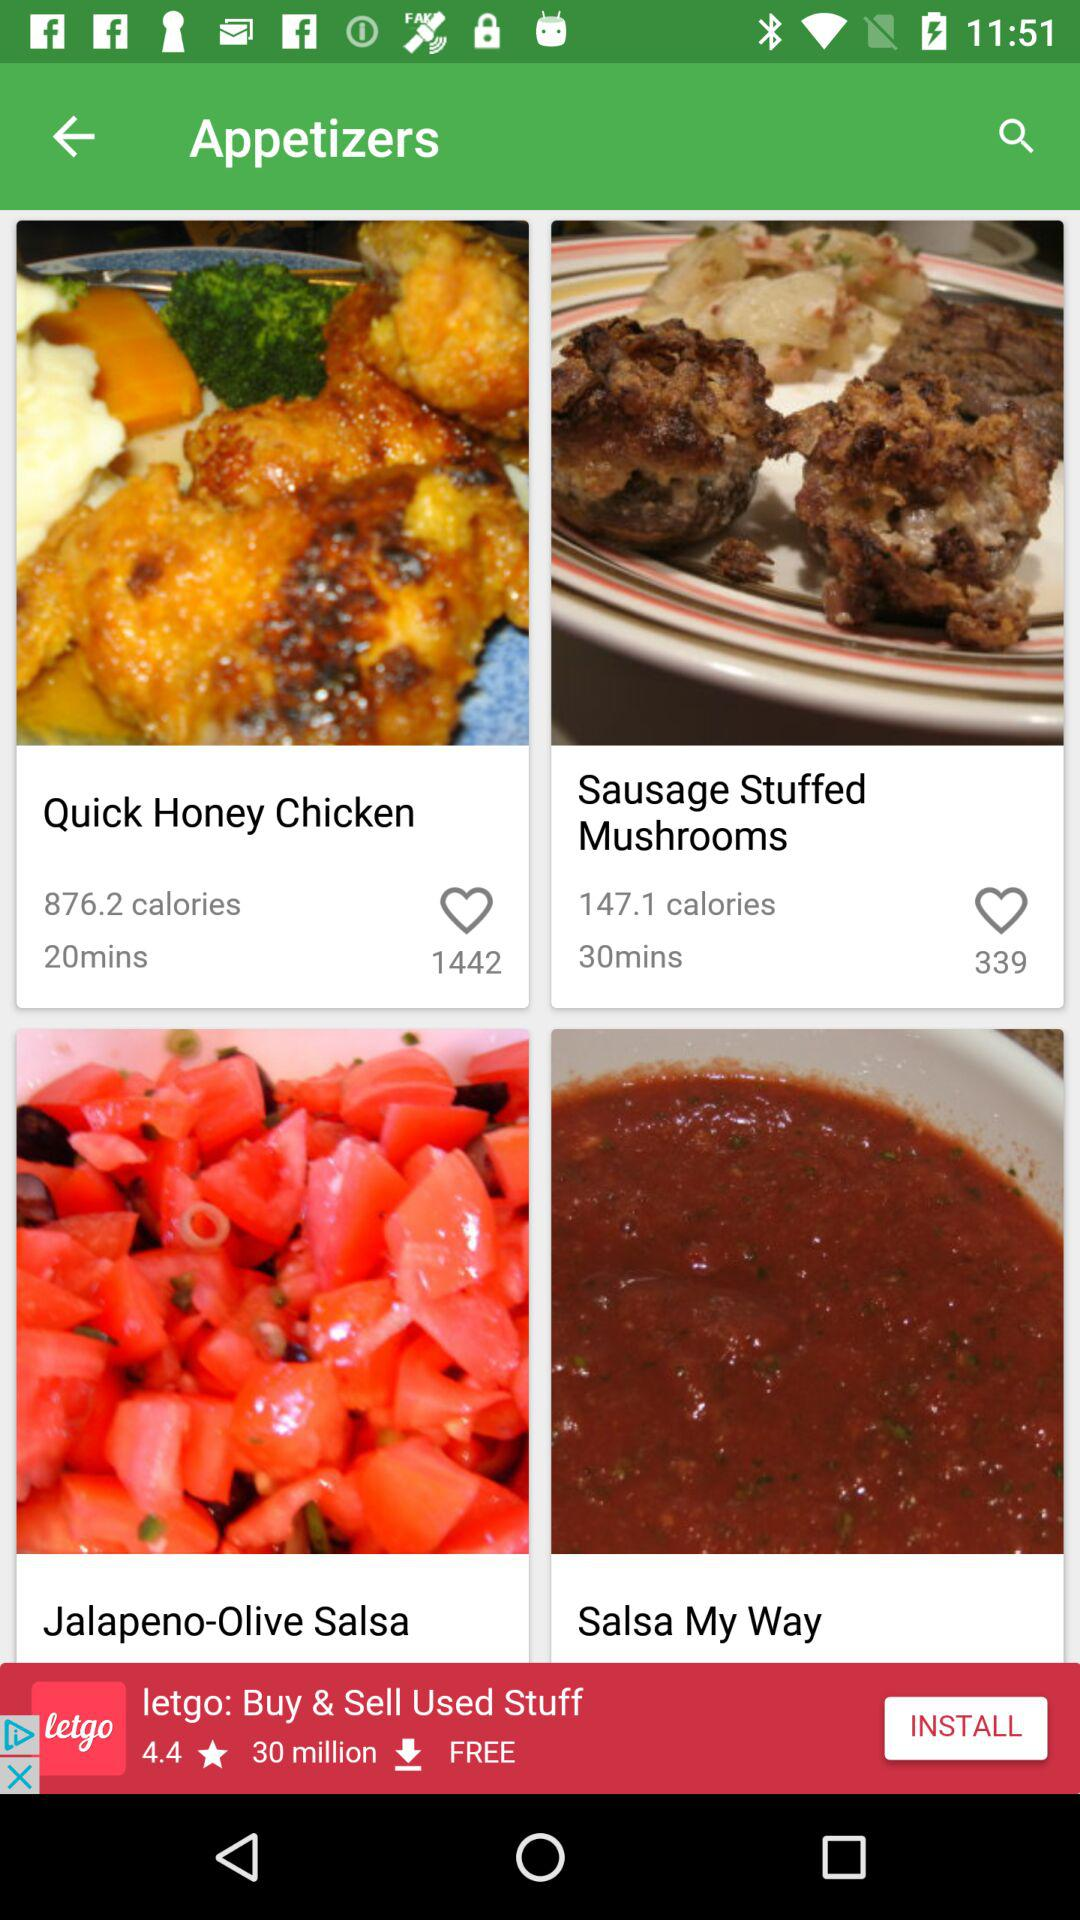How many calories are present in quick honey chicken? There are 876.2 calories present in quick honey chicken. 